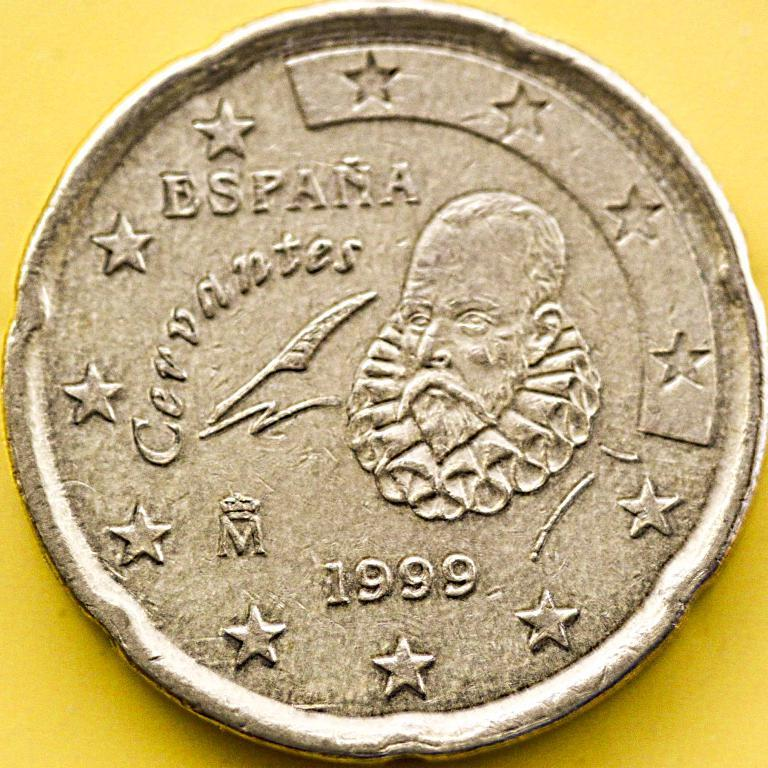<image>
Write a terse but informative summary of the picture. A Spanish coin from 1999 features a border made of stars. 